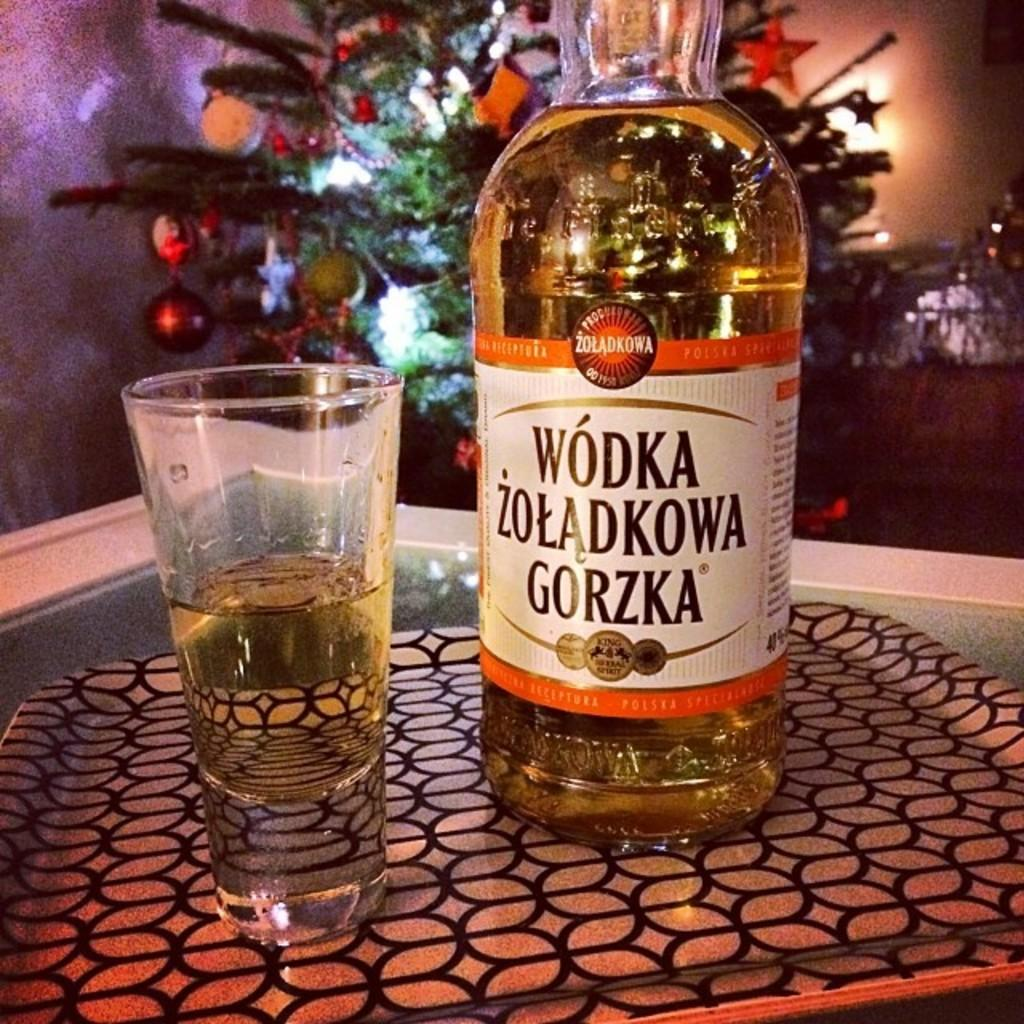<image>
Relay a brief, clear account of the picture shown. A label in a foreign language identifies a large bottle of vodka. 